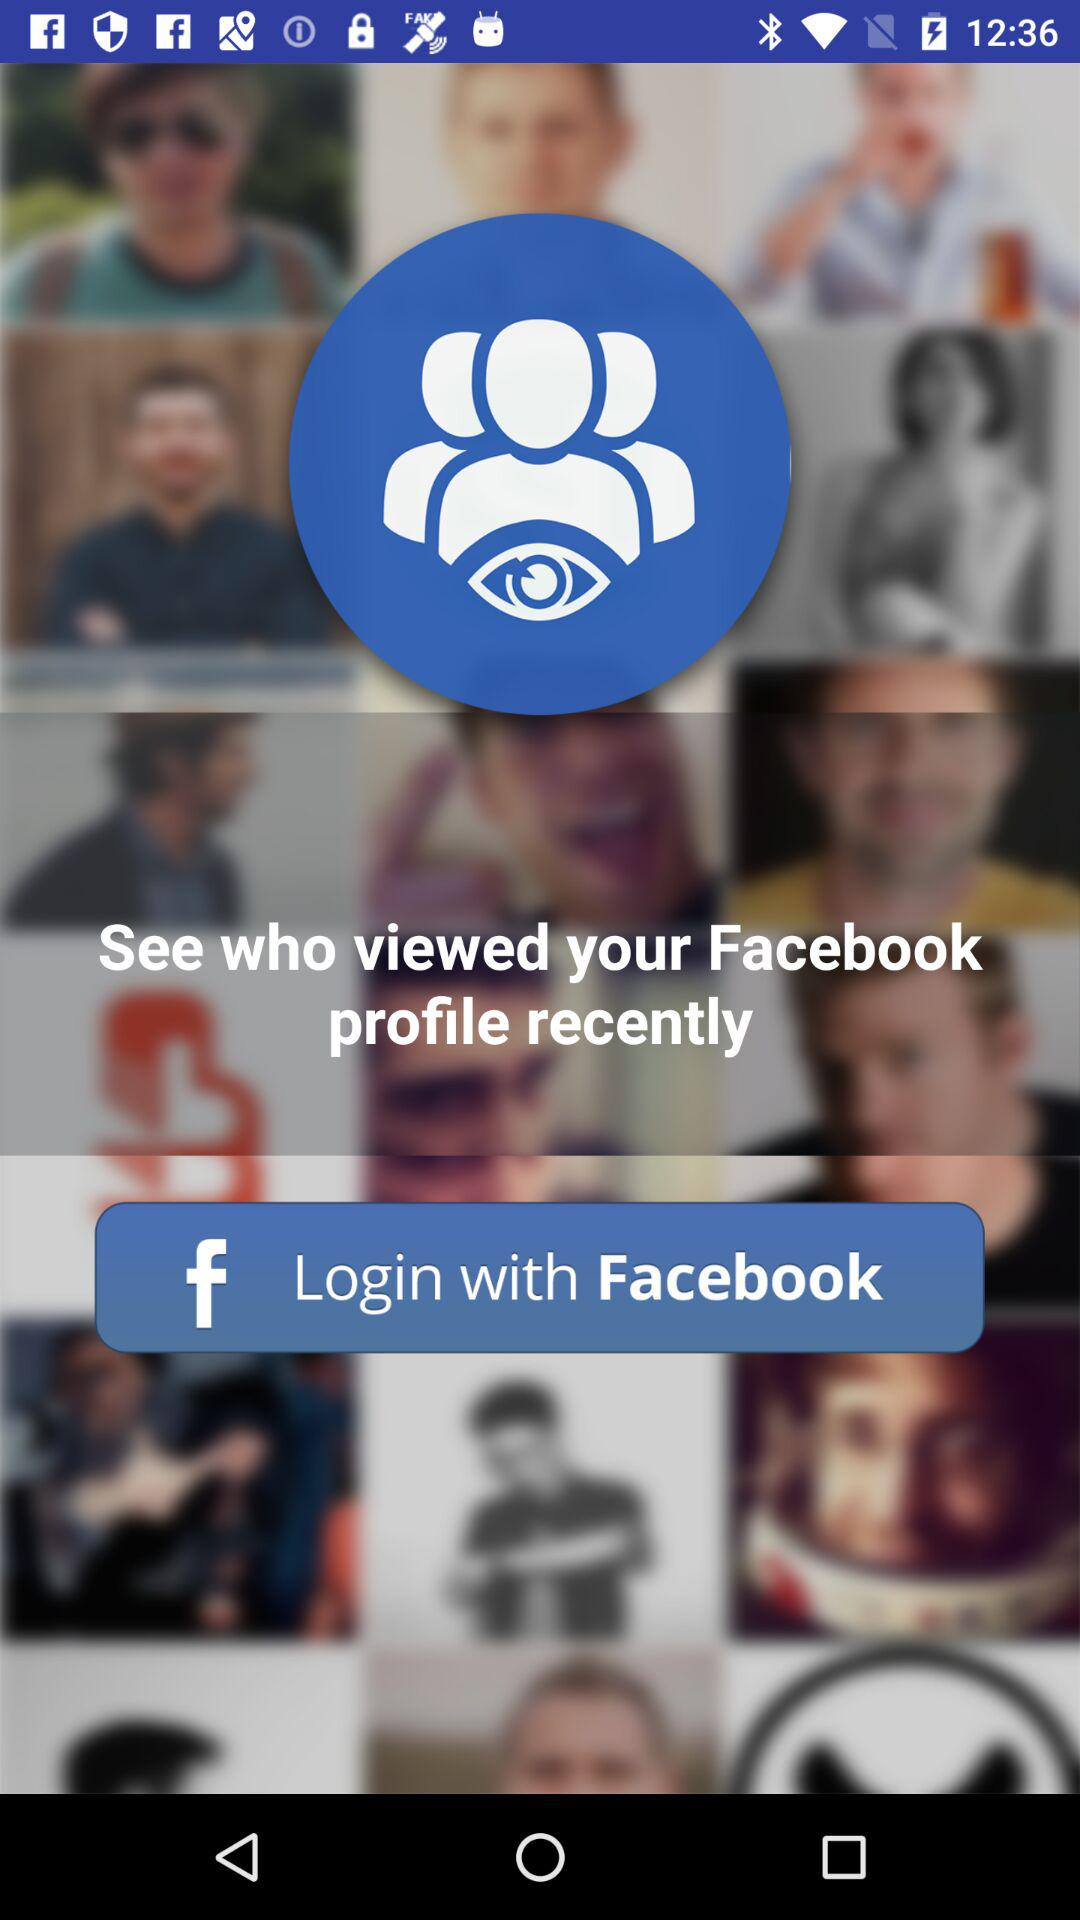Through what application can we log in? You can log in through "Facebook". 